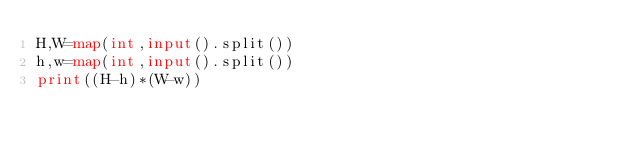<code> <loc_0><loc_0><loc_500><loc_500><_Python_>H,W=map(int,input().split())
h,w=map(int,input().split())
print((H-h)*(W-w))</code> 